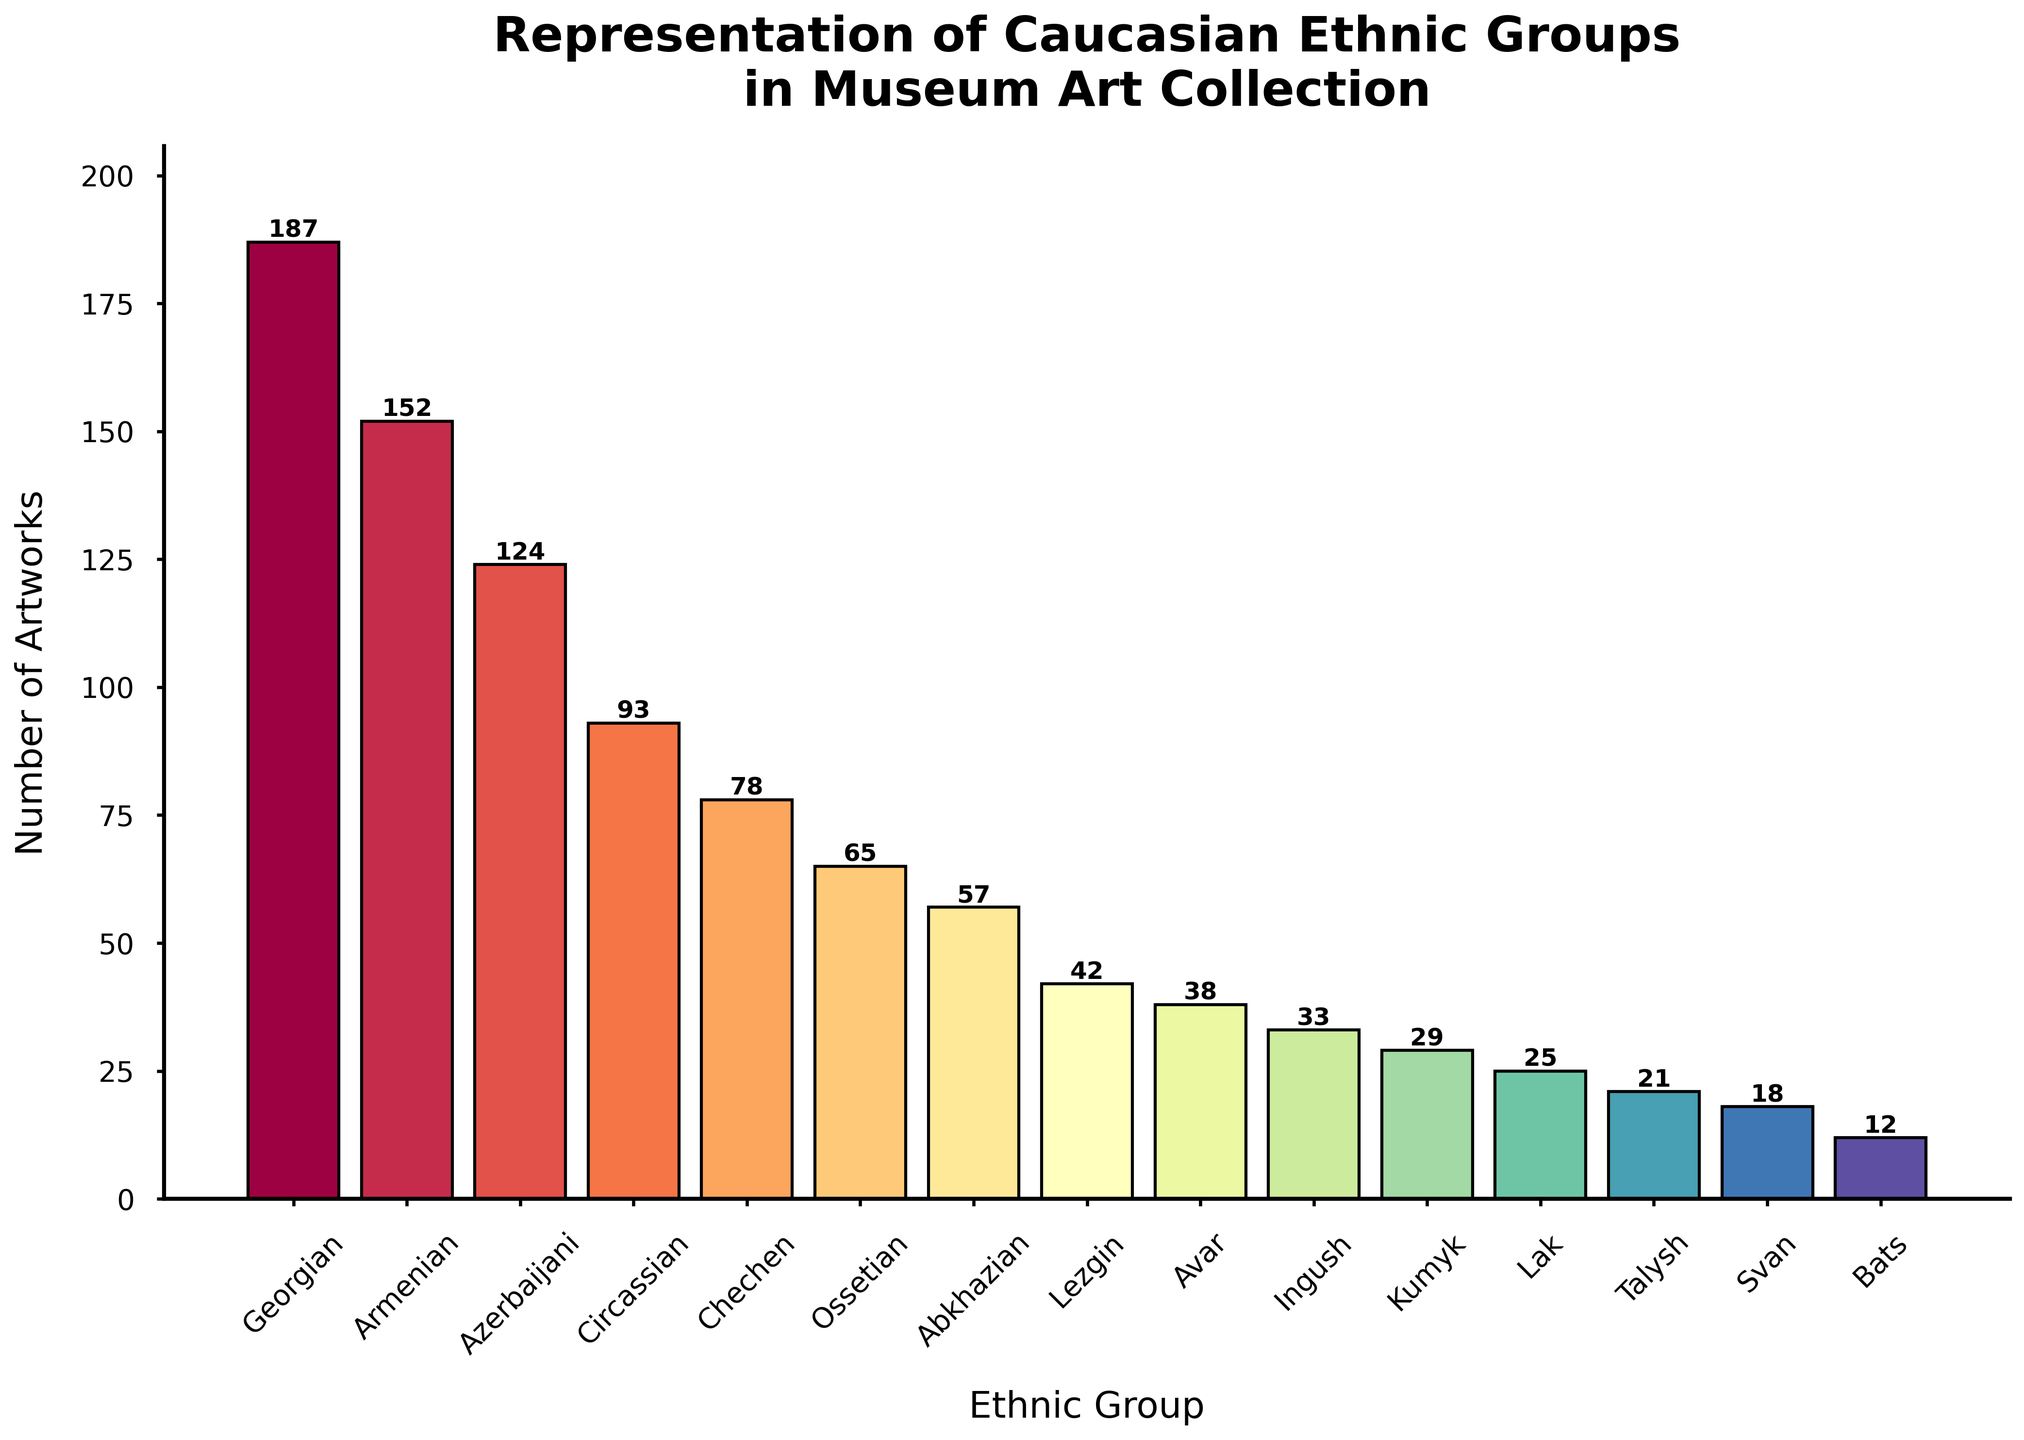What's the total number of artworks represented by the top three ethnic groups? Summing the number of artworks for the top three ethnic groups: Georgian (187), Armenian (152), and Azerbaijani (124): 187 + 152 + 124 = 463
Answer: 463 Which ethnic group has the fewest represented artworks and how many do they have? By looking at the heights of the bars, the Bats ethnic group has the fewest number of artworks with a count of 12
Answer: Bats, 12 What's the difference in the number of artworks between the Circassian and Chechen ethnic groups? Subtracting the number of artworks of Chechens (78) from Circassians (93): 93 - 78 = 15
Answer: 15 What's the average number of artworks in the museum's collection for all ethnic groups? Summing the number of artworks for all groups and dividing by the number of groups: (187 + 152 + 124 + 93 + 78 + 65 + 57 + 42 + 38 + 33 + 29 + 25 + 21 + 18 + 12) / 15 = 974 / 15 ≈ 64.93
Answer: 64.93 How many more artworks do the Georgians have compared to the Abkhazians? Subtracting the number of artworks of Abkhazians (57) from Georgians (187): 187 - 57 = 130
Answer: 130 Among the ethnic groups with fewer than 50 artworks, which one has the highest representation? Among the groups with fewer than 50 artworks (Lezgin, Avar, Ingush, Kumyk, Lak, Talysh, Svan, Bats), Lezgin has the highest number with 42
Answer: Lezgin, 42 What's the combined representation of Kumyk and Lak ethnic groups in the art collection? Summing the number of artworks for Kumyk (29) and Lak (25): 29 + 25 = 54
Answer: 54 Which ethnic group's representation in the museum is closest to the average number of artworks? The average number of artworks is approximately 64.93. The Ossetian ethnic group's count of 65 is closest to this average
Answer: Ossetian, 65 What is the ratio of the number of artworks of Georgian to Svan ethnic groups? Dividing the number of artworks of Georgians (187) by that of Svan (18): 187 / 18 ≈ 10.39
Answer: 10.39 